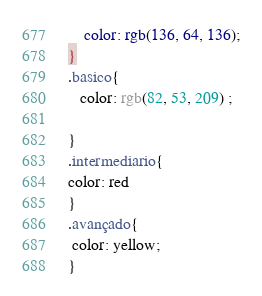<code> <loc_0><loc_0><loc_500><loc_500><_CSS_>    color: rgb(136, 64, 136);
}
.basico{
   color: rgb(82, 53, 209) ;

}
.intermediario{
color: red
}
.avançado{
 color: yellow;
}</code> 